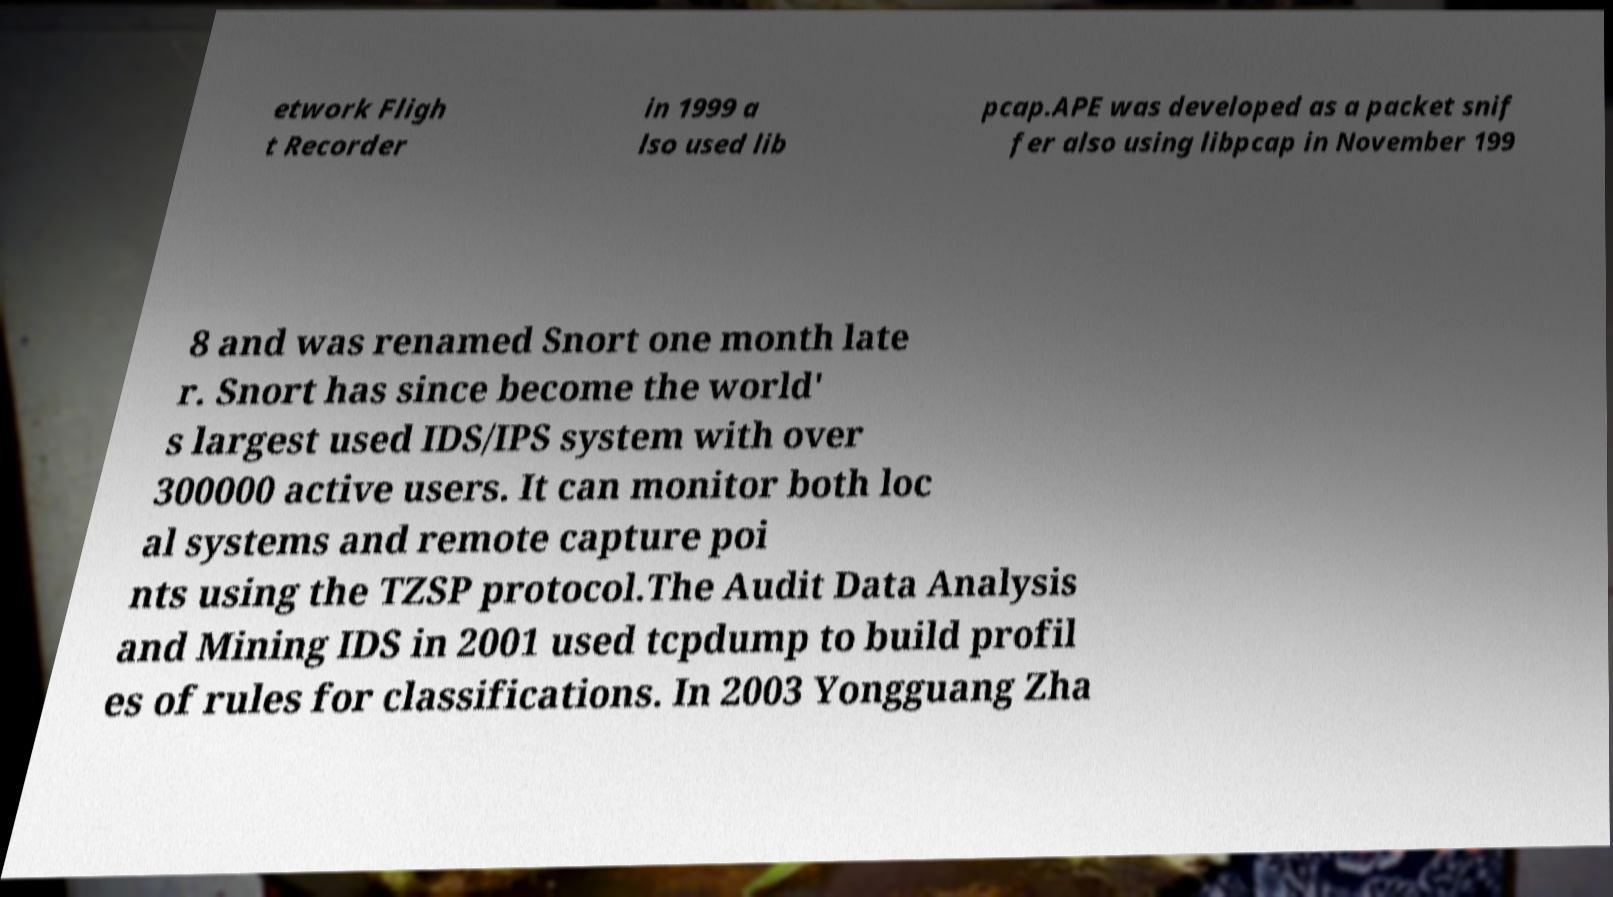For documentation purposes, I need the text within this image transcribed. Could you provide that? etwork Fligh t Recorder in 1999 a lso used lib pcap.APE was developed as a packet snif fer also using libpcap in November 199 8 and was renamed Snort one month late r. Snort has since become the world' s largest used IDS/IPS system with over 300000 active users. It can monitor both loc al systems and remote capture poi nts using the TZSP protocol.The Audit Data Analysis and Mining IDS in 2001 used tcpdump to build profil es of rules for classifications. In 2003 Yongguang Zha 